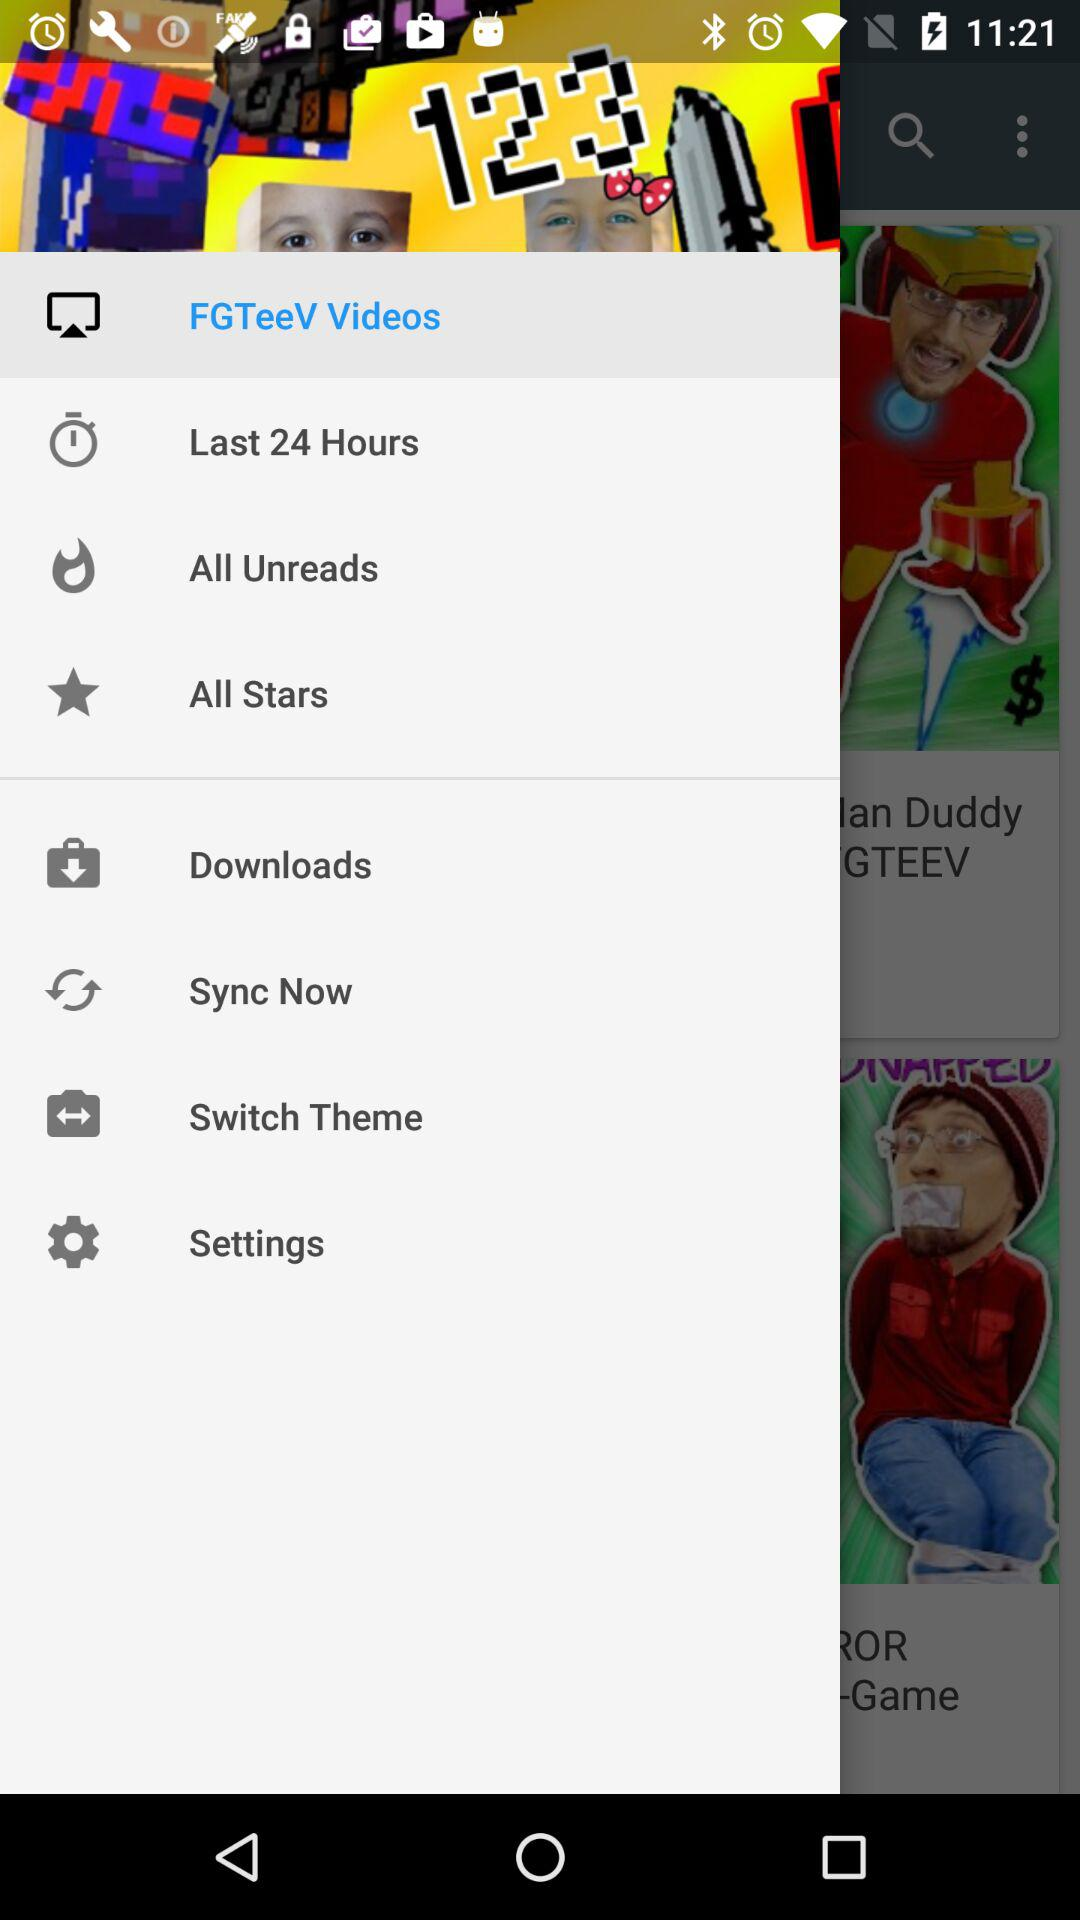Which item is selected? The item "FGTeeV Videos" is selected. 